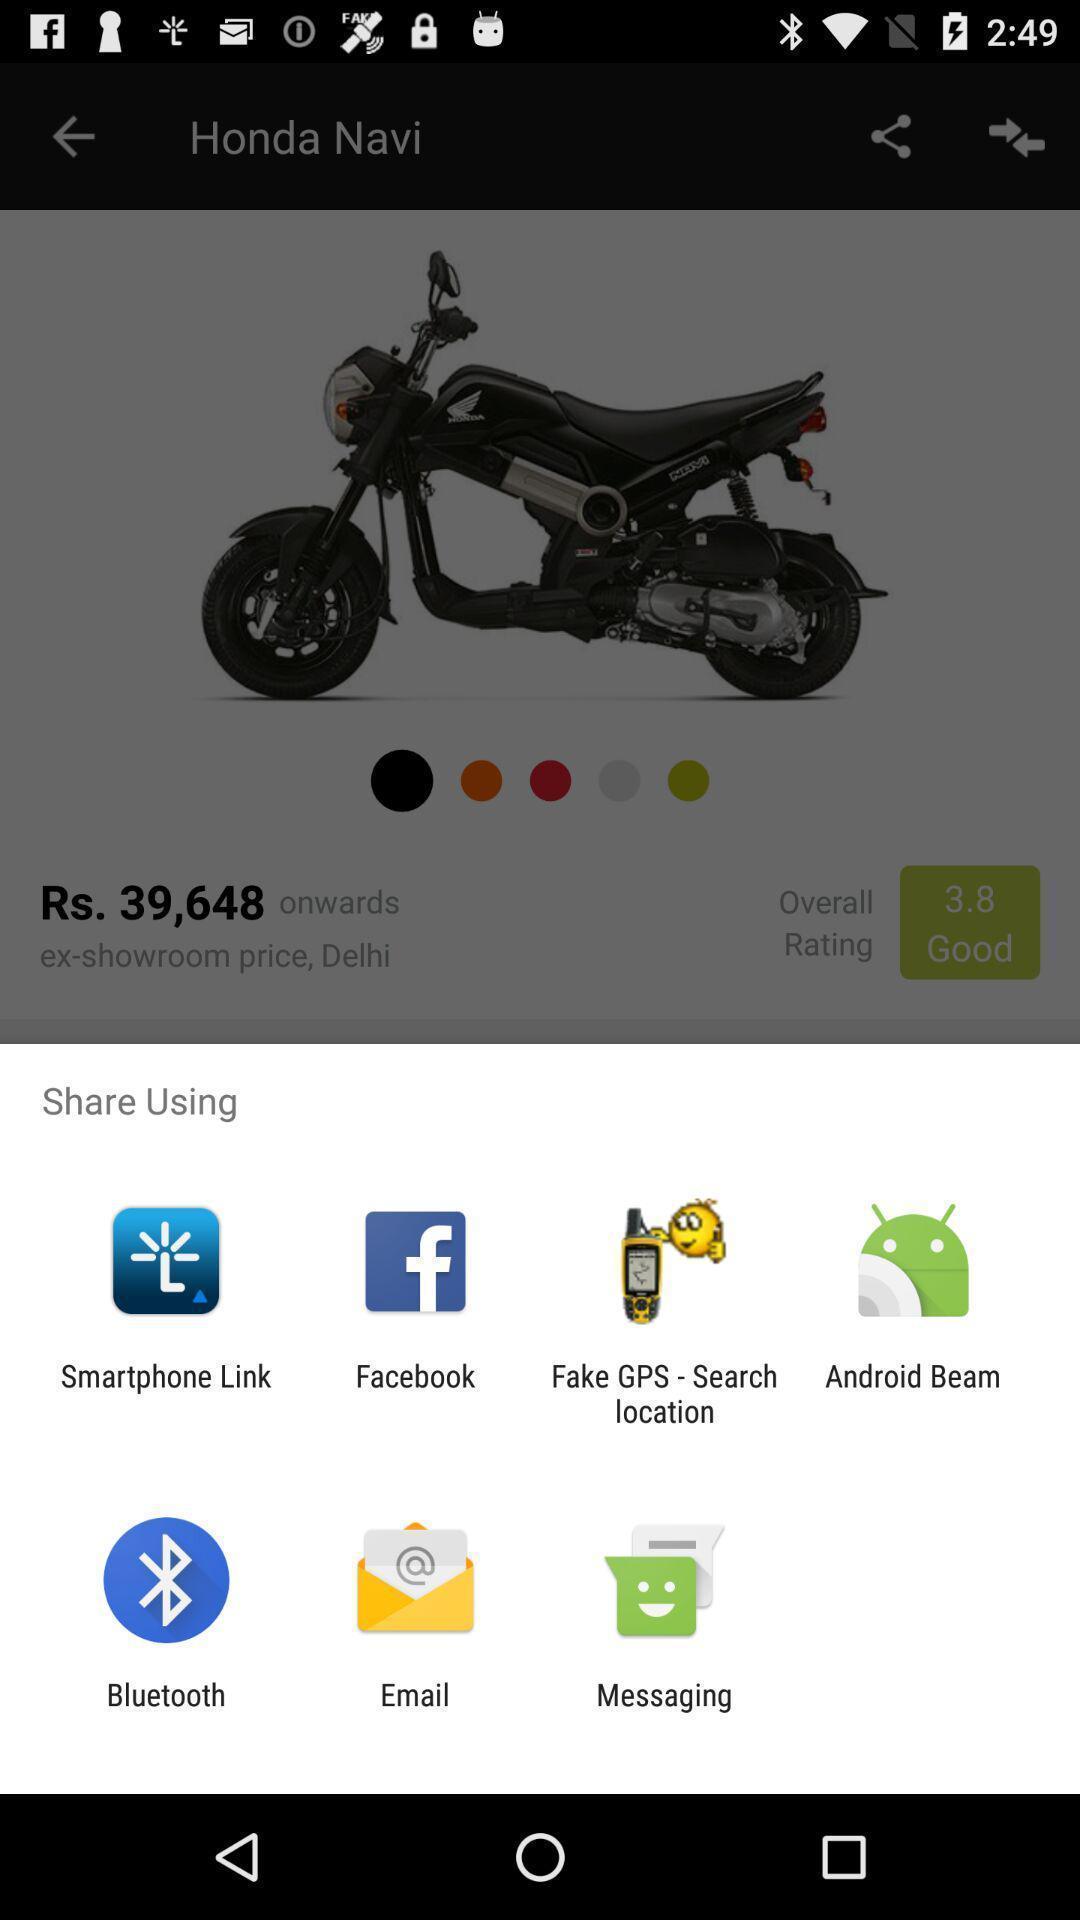Summarize the information in this screenshot. Pop-up shows share option with multiple applications. 